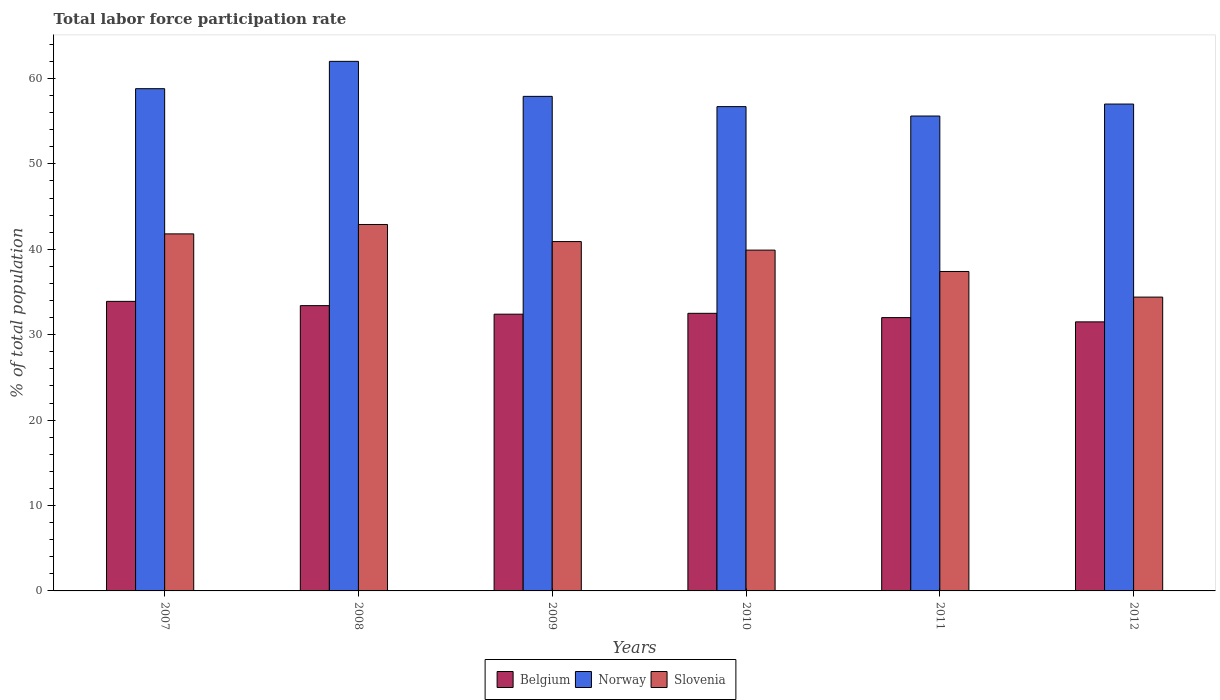How many different coloured bars are there?
Your response must be concise. 3. How many groups of bars are there?
Your answer should be very brief. 6. Are the number of bars on each tick of the X-axis equal?
Give a very brief answer. Yes. How many bars are there on the 2nd tick from the right?
Keep it short and to the point. 3. What is the label of the 5th group of bars from the left?
Offer a very short reply. 2011. What is the total labor force participation rate in Norway in 2010?
Keep it short and to the point. 56.7. Across all years, what is the maximum total labor force participation rate in Norway?
Give a very brief answer. 62. Across all years, what is the minimum total labor force participation rate in Belgium?
Ensure brevity in your answer.  31.5. In which year was the total labor force participation rate in Norway maximum?
Provide a succinct answer. 2008. What is the total total labor force participation rate in Belgium in the graph?
Keep it short and to the point. 195.7. What is the difference between the total labor force participation rate in Slovenia in 2007 and that in 2010?
Give a very brief answer. 1.9. What is the difference between the total labor force participation rate in Norway in 2008 and the total labor force participation rate in Slovenia in 2009?
Provide a succinct answer. 21.1. What is the average total labor force participation rate in Slovenia per year?
Give a very brief answer. 39.55. What is the ratio of the total labor force participation rate in Belgium in 2008 to that in 2011?
Provide a succinct answer. 1.04. Is the total labor force participation rate in Slovenia in 2008 less than that in 2011?
Provide a short and direct response. No. What is the difference between the highest and the second highest total labor force participation rate in Norway?
Ensure brevity in your answer.  3.2. What is the difference between the highest and the lowest total labor force participation rate in Norway?
Offer a very short reply. 6.4. In how many years, is the total labor force participation rate in Belgium greater than the average total labor force participation rate in Belgium taken over all years?
Give a very brief answer. 2. Is the sum of the total labor force participation rate in Norway in 2007 and 2011 greater than the maximum total labor force participation rate in Belgium across all years?
Your response must be concise. Yes. What does the 1st bar from the left in 2007 represents?
Your answer should be compact. Belgium. Are all the bars in the graph horizontal?
Keep it short and to the point. No. What is the difference between two consecutive major ticks on the Y-axis?
Make the answer very short. 10. Are the values on the major ticks of Y-axis written in scientific E-notation?
Ensure brevity in your answer.  No. Does the graph contain any zero values?
Offer a very short reply. No. How many legend labels are there?
Your answer should be very brief. 3. What is the title of the graph?
Your answer should be very brief. Total labor force participation rate. Does "Pakistan" appear as one of the legend labels in the graph?
Your answer should be very brief. No. What is the label or title of the X-axis?
Your answer should be compact. Years. What is the label or title of the Y-axis?
Ensure brevity in your answer.  % of total population. What is the % of total population in Belgium in 2007?
Your response must be concise. 33.9. What is the % of total population of Norway in 2007?
Give a very brief answer. 58.8. What is the % of total population in Slovenia in 2007?
Keep it short and to the point. 41.8. What is the % of total population of Belgium in 2008?
Make the answer very short. 33.4. What is the % of total population of Norway in 2008?
Offer a terse response. 62. What is the % of total population of Slovenia in 2008?
Your response must be concise. 42.9. What is the % of total population in Belgium in 2009?
Keep it short and to the point. 32.4. What is the % of total population in Norway in 2009?
Your answer should be compact. 57.9. What is the % of total population in Slovenia in 2009?
Ensure brevity in your answer.  40.9. What is the % of total population of Belgium in 2010?
Provide a short and direct response. 32.5. What is the % of total population of Norway in 2010?
Your answer should be compact. 56.7. What is the % of total population in Slovenia in 2010?
Offer a very short reply. 39.9. What is the % of total population of Belgium in 2011?
Offer a terse response. 32. What is the % of total population in Norway in 2011?
Offer a very short reply. 55.6. What is the % of total population of Slovenia in 2011?
Your answer should be very brief. 37.4. What is the % of total population of Belgium in 2012?
Ensure brevity in your answer.  31.5. What is the % of total population in Norway in 2012?
Keep it short and to the point. 57. What is the % of total population of Slovenia in 2012?
Your answer should be very brief. 34.4. Across all years, what is the maximum % of total population of Belgium?
Keep it short and to the point. 33.9. Across all years, what is the maximum % of total population in Norway?
Your response must be concise. 62. Across all years, what is the maximum % of total population of Slovenia?
Offer a terse response. 42.9. Across all years, what is the minimum % of total population of Belgium?
Your answer should be very brief. 31.5. Across all years, what is the minimum % of total population in Norway?
Provide a succinct answer. 55.6. Across all years, what is the minimum % of total population in Slovenia?
Provide a succinct answer. 34.4. What is the total % of total population of Belgium in the graph?
Give a very brief answer. 195.7. What is the total % of total population in Norway in the graph?
Provide a short and direct response. 348. What is the total % of total population of Slovenia in the graph?
Keep it short and to the point. 237.3. What is the difference between the % of total population of Norway in 2007 and that in 2008?
Offer a very short reply. -3.2. What is the difference between the % of total population of Slovenia in 2007 and that in 2008?
Ensure brevity in your answer.  -1.1. What is the difference between the % of total population of Belgium in 2007 and that in 2009?
Provide a succinct answer. 1.5. What is the difference between the % of total population in Norway in 2007 and that in 2009?
Give a very brief answer. 0.9. What is the difference between the % of total population of Norway in 2007 and that in 2010?
Make the answer very short. 2.1. What is the difference between the % of total population of Slovenia in 2007 and that in 2010?
Keep it short and to the point. 1.9. What is the difference between the % of total population in Belgium in 2007 and that in 2012?
Keep it short and to the point. 2.4. What is the difference between the % of total population of Norway in 2007 and that in 2012?
Provide a succinct answer. 1.8. What is the difference between the % of total population in Norway in 2008 and that in 2009?
Provide a short and direct response. 4.1. What is the difference between the % of total population in Belgium in 2008 and that in 2010?
Give a very brief answer. 0.9. What is the difference between the % of total population of Norway in 2008 and that in 2010?
Give a very brief answer. 5.3. What is the difference between the % of total population in Norway in 2008 and that in 2011?
Your answer should be very brief. 6.4. What is the difference between the % of total population in Norway in 2008 and that in 2012?
Your answer should be compact. 5. What is the difference between the % of total population in Belgium in 2009 and that in 2010?
Provide a short and direct response. -0.1. What is the difference between the % of total population in Norway in 2009 and that in 2010?
Ensure brevity in your answer.  1.2. What is the difference between the % of total population of Norway in 2009 and that in 2011?
Your answer should be compact. 2.3. What is the difference between the % of total population in Belgium in 2009 and that in 2012?
Offer a very short reply. 0.9. What is the difference between the % of total population of Norway in 2009 and that in 2012?
Provide a short and direct response. 0.9. What is the difference between the % of total population in Belgium in 2010 and that in 2011?
Ensure brevity in your answer.  0.5. What is the difference between the % of total population of Norway in 2010 and that in 2011?
Provide a succinct answer. 1.1. What is the difference between the % of total population in Slovenia in 2010 and that in 2011?
Keep it short and to the point. 2.5. What is the difference between the % of total population in Slovenia in 2010 and that in 2012?
Make the answer very short. 5.5. What is the difference between the % of total population in Slovenia in 2011 and that in 2012?
Your response must be concise. 3. What is the difference between the % of total population in Belgium in 2007 and the % of total population in Norway in 2008?
Offer a very short reply. -28.1. What is the difference between the % of total population of Belgium in 2007 and the % of total population of Norway in 2009?
Your answer should be compact. -24. What is the difference between the % of total population of Belgium in 2007 and the % of total population of Slovenia in 2009?
Offer a very short reply. -7. What is the difference between the % of total population in Belgium in 2007 and the % of total population in Norway in 2010?
Make the answer very short. -22.8. What is the difference between the % of total population in Belgium in 2007 and the % of total population in Slovenia in 2010?
Provide a succinct answer. -6. What is the difference between the % of total population in Belgium in 2007 and the % of total population in Norway in 2011?
Ensure brevity in your answer.  -21.7. What is the difference between the % of total population in Norway in 2007 and the % of total population in Slovenia in 2011?
Provide a short and direct response. 21.4. What is the difference between the % of total population of Belgium in 2007 and the % of total population of Norway in 2012?
Make the answer very short. -23.1. What is the difference between the % of total population of Belgium in 2007 and the % of total population of Slovenia in 2012?
Ensure brevity in your answer.  -0.5. What is the difference between the % of total population of Norway in 2007 and the % of total population of Slovenia in 2012?
Your answer should be compact. 24.4. What is the difference between the % of total population of Belgium in 2008 and the % of total population of Norway in 2009?
Provide a succinct answer. -24.5. What is the difference between the % of total population in Belgium in 2008 and the % of total population in Slovenia in 2009?
Provide a short and direct response. -7.5. What is the difference between the % of total population of Norway in 2008 and the % of total population of Slovenia in 2009?
Your response must be concise. 21.1. What is the difference between the % of total population of Belgium in 2008 and the % of total population of Norway in 2010?
Make the answer very short. -23.3. What is the difference between the % of total population of Belgium in 2008 and the % of total population of Slovenia in 2010?
Your answer should be very brief. -6.5. What is the difference between the % of total population of Norway in 2008 and the % of total population of Slovenia in 2010?
Provide a short and direct response. 22.1. What is the difference between the % of total population of Belgium in 2008 and the % of total population of Norway in 2011?
Provide a succinct answer. -22.2. What is the difference between the % of total population in Norway in 2008 and the % of total population in Slovenia in 2011?
Offer a very short reply. 24.6. What is the difference between the % of total population in Belgium in 2008 and the % of total population in Norway in 2012?
Offer a terse response. -23.6. What is the difference between the % of total population in Belgium in 2008 and the % of total population in Slovenia in 2012?
Ensure brevity in your answer.  -1. What is the difference between the % of total population of Norway in 2008 and the % of total population of Slovenia in 2012?
Your answer should be very brief. 27.6. What is the difference between the % of total population in Belgium in 2009 and the % of total population in Norway in 2010?
Offer a terse response. -24.3. What is the difference between the % of total population of Belgium in 2009 and the % of total population of Slovenia in 2010?
Provide a short and direct response. -7.5. What is the difference between the % of total population of Belgium in 2009 and the % of total population of Norway in 2011?
Your answer should be very brief. -23.2. What is the difference between the % of total population in Belgium in 2009 and the % of total population in Slovenia in 2011?
Your answer should be very brief. -5. What is the difference between the % of total population of Belgium in 2009 and the % of total population of Norway in 2012?
Offer a very short reply. -24.6. What is the difference between the % of total population of Belgium in 2010 and the % of total population of Norway in 2011?
Your response must be concise. -23.1. What is the difference between the % of total population in Belgium in 2010 and the % of total population in Slovenia in 2011?
Provide a short and direct response. -4.9. What is the difference between the % of total population in Norway in 2010 and the % of total population in Slovenia in 2011?
Offer a terse response. 19.3. What is the difference between the % of total population in Belgium in 2010 and the % of total population in Norway in 2012?
Provide a succinct answer. -24.5. What is the difference between the % of total population of Belgium in 2010 and the % of total population of Slovenia in 2012?
Your answer should be very brief. -1.9. What is the difference between the % of total population in Norway in 2010 and the % of total population in Slovenia in 2012?
Ensure brevity in your answer.  22.3. What is the difference between the % of total population of Norway in 2011 and the % of total population of Slovenia in 2012?
Your answer should be very brief. 21.2. What is the average % of total population of Belgium per year?
Make the answer very short. 32.62. What is the average % of total population of Norway per year?
Your answer should be compact. 58. What is the average % of total population of Slovenia per year?
Your response must be concise. 39.55. In the year 2007, what is the difference between the % of total population of Belgium and % of total population of Norway?
Ensure brevity in your answer.  -24.9. In the year 2007, what is the difference between the % of total population in Belgium and % of total population in Slovenia?
Offer a terse response. -7.9. In the year 2008, what is the difference between the % of total population in Belgium and % of total population in Norway?
Offer a very short reply. -28.6. In the year 2008, what is the difference between the % of total population of Belgium and % of total population of Slovenia?
Your response must be concise. -9.5. In the year 2009, what is the difference between the % of total population in Belgium and % of total population in Norway?
Ensure brevity in your answer.  -25.5. In the year 2009, what is the difference between the % of total population in Belgium and % of total population in Slovenia?
Provide a short and direct response. -8.5. In the year 2009, what is the difference between the % of total population in Norway and % of total population in Slovenia?
Provide a short and direct response. 17. In the year 2010, what is the difference between the % of total population in Belgium and % of total population in Norway?
Your response must be concise. -24.2. In the year 2010, what is the difference between the % of total population of Belgium and % of total population of Slovenia?
Provide a short and direct response. -7.4. In the year 2011, what is the difference between the % of total population of Belgium and % of total population of Norway?
Your answer should be compact. -23.6. In the year 2012, what is the difference between the % of total population in Belgium and % of total population in Norway?
Make the answer very short. -25.5. In the year 2012, what is the difference between the % of total population of Norway and % of total population of Slovenia?
Make the answer very short. 22.6. What is the ratio of the % of total population of Norway in 2007 to that in 2008?
Your answer should be compact. 0.95. What is the ratio of the % of total population of Slovenia in 2007 to that in 2008?
Your response must be concise. 0.97. What is the ratio of the % of total population in Belgium in 2007 to that in 2009?
Your answer should be compact. 1.05. What is the ratio of the % of total population in Norway in 2007 to that in 2009?
Make the answer very short. 1.02. What is the ratio of the % of total population of Belgium in 2007 to that in 2010?
Make the answer very short. 1.04. What is the ratio of the % of total population of Norway in 2007 to that in 2010?
Provide a succinct answer. 1.04. What is the ratio of the % of total population in Slovenia in 2007 to that in 2010?
Your answer should be compact. 1.05. What is the ratio of the % of total population of Belgium in 2007 to that in 2011?
Offer a very short reply. 1.06. What is the ratio of the % of total population of Norway in 2007 to that in 2011?
Keep it short and to the point. 1.06. What is the ratio of the % of total population of Slovenia in 2007 to that in 2011?
Give a very brief answer. 1.12. What is the ratio of the % of total population of Belgium in 2007 to that in 2012?
Provide a short and direct response. 1.08. What is the ratio of the % of total population of Norway in 2007 to that in 2012?
Offer a very short reply. 1.03. What is the ratio of the % of total population in Slovenia in 2007 to that in 2012?
Provide a succinct answer. 1.22. What is the ratio of the % of total population of Belgium in 2008 to that in 2009?
Provide a short and direct response. 1.03. What is the ratio of the % of total population of Norway in 2008 to that in 2009?
Provide a succinct answer. 1.07. What is the ratio of the % of total population in Slovenia in 2008 to that in 2009?
Offer a very short reply. 1.05. What is the ratio of the % of total population in Belgium in 2008 to that in 2010?
Make the answer very short. 1.03. What is the ratio of the % of total population of Norway in 2008 to that in 2010?
Make the answer very short. 1.09. What is the ratio of the % of total population in Slovenia in 2008 to that in 2010?
Your answer should be very brief. 1.08. What is the ratio of the % of total population of Belgium in 2008 to that in 2011?
Provide a short and direct response. 1.04. What is the ratio of the % of total population of Norway in 2008 to that in 2011?
Your answer should be compact. 1.12. What is the ratio of the % of total population of Slovenia in 2008 to that in 2011?
Make the answer very short. 1.15. What is the ratio of the % of total population of Belgium in 2008 to that in 2012?
Provide a succinct answer. 1.06. What is the ratio of the % of total population of Norway in 2008 to that in 2012?
Provide a succinct answer. 1.09. What is the ratio of the % of total population of Slovenia in 2008 to that in 2012?
Provide a short and direct response. 1.25. What is the ratio of the % of total population of Norway in 2009 to that in 2010?
Offer a very short reply. 1.02. What is the ratio of the % of total population of Slovenia in 2009 to that in 2010?
Provide a short and direct response. 1.03. What is the ratio of the % of total population of Belgium in 2009 to that in 2011?
Keep it short and to the point. 1.01. What is the ratio of the % of total population in Norway in 2009 to that in 2011?
Your response must be concise. 1.04. What is the ratio of the % of total population in Slovenia in 2009 to that in 2011?
Provide a succinct answer. 1.09. What is the ratio of the % of total population of Belgium in 2009 to that in 2012?
Offer a very short reply. 1.03. What is the ratio of the % of total population in Norway in 2009 to that in 2012?
Offer a terse response. 1.02. What is the ratio of the % of total population in Slovenia in 2009 to that in 2012?
Your response must be concise. 1.19. What is the ratio of the % of total population of Belgium in 2010 to that in 2011?
Give a very brief answer. 1.02. What is the ratio of the % of total population in Norway in 2010 to that in 2011?
Provide a succinct answer. 1.02. What is the ratio of the % of total population of Slovenia in 2010 to that in 2011?
Provide a short and direct response. 1.07. What is the ratio of the % of total population in Belgium in 2010 to that in 2012?
Keep it short and to the point. 1.03. What is the ratio of the % of total population of Slovenia in 2010 to that in 2012?
Offer a very short reply. 1.16. What is the ratio of the % of total population in Belgium in 2011 to that in 2012?
Provide a succinct answer. 1.02. What is the ratio of the % of total population in Norway in 2011 to that in 2012?
Offer a very short reply. 0.98. What is the ratio of the % of total population in Slovenia in 2011 to that in 2012?
Provide a short and direct response. 1.09. What is the difference between the highest and the second highest % of total population of Belgium?
Make the answer very short. 0.5. What is the difference between the highest and the second highest % of total population of Slovenia?
Offer a terse response. 1.1. What is the difference between the highest and the lowest % of total population of Belgium?
Your answer should be very brief. 2.4. What is the difference between the highest and the lowest % of total population in Norway?
Offer a terse response. 6.4. What is the difference between the highest and the lowest % of total population of Slovenia?
Offer a very short reply. 8.5. 